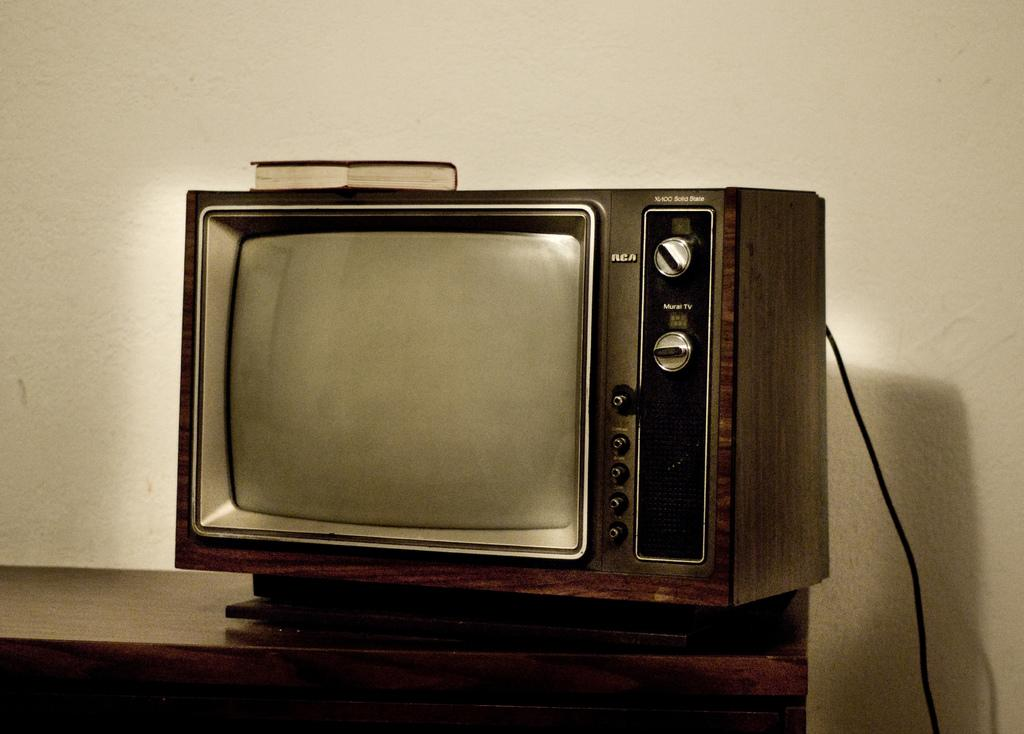Provide a one-sentence caption for the provided image. a very old RCA television sits atop a wood table. 